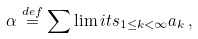Convert formula to latex. <formula><loc_0><loc_0><loc_500><loc_500>\alpha \stackrel { d e f } { = } \sum \lim i t s _ { 1 \leq k < \infty } a _ { k } \, ,</formula> 